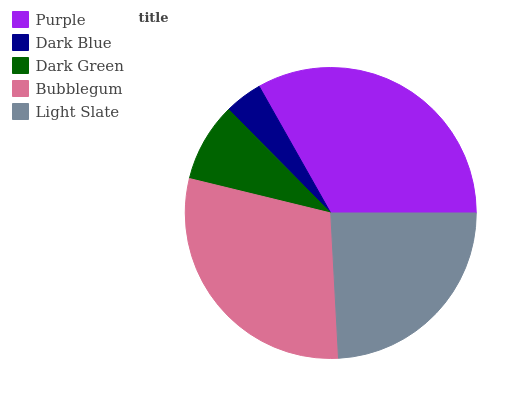Is Dark Blue the minimum?
Answer yes or no. Yes. Is Purple the maximum?
Answer yes or no. Yes. Is Dark Green the minimum?
Answer yes or no. No. Is Dark Green the maximum?
Answer yes or no. No. Is Dark Green greater than Dark Blue?
Answer yes or no. Yes. Is Dark Blue less than Dark Green?
Answer yes or no. Yes. Is Dark Blue greater than Dark Green?
Answer yes or no. No. Is Dark Green less than Dark Blue?
Answer yes or no. No. Is Light Slate the high median?
Answer yes or no. Yes. Is Light Slate the low median?
Answer yes or no. Yes. Is Dark Green the high median?
Answer yes or no. No. Is Purple the low median?
Answer yes or no. No. 